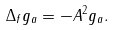Convert formula to latex. <formula><loc_0><loc_0><loc_500><loc_500>\Delta _ { f } g _ { a } = - \| A \| ^ { 2 } g _ { a } .</formula> 